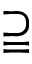<formula> <loc_0><loc_0><loc_500><loc_500>\supseteqq</formula> 